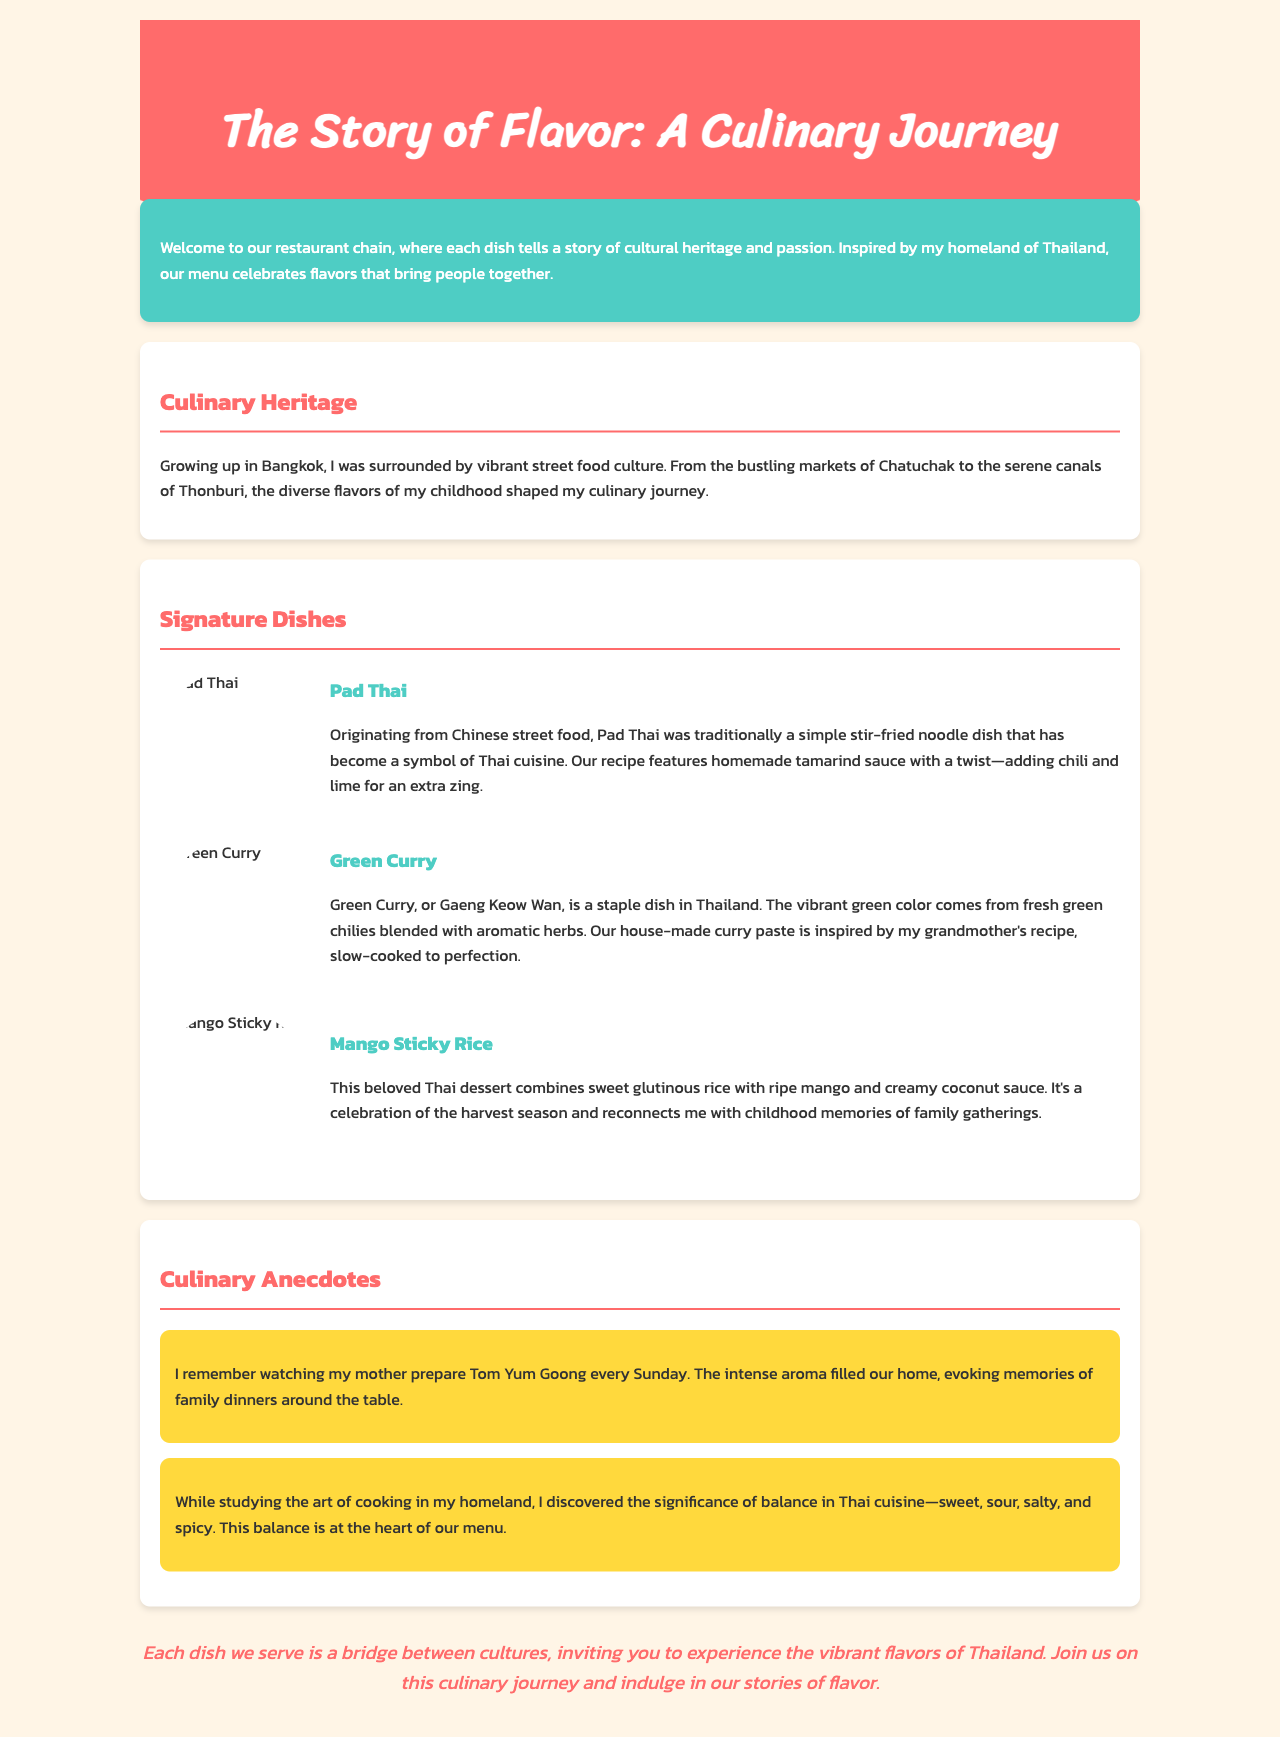What is the name of the restaurant chain? The brochure introduces the restaurant chain as celebrating flavors inspired by the owner's homeland.
Answer: Story of Flavor What is the main inspiration for the restaurant's menu? The brochure mentions that the menu is inspired by the owner's cultural heritage.
Answer: Culinary heritage What dish is described as a symbol of Thai cuisine? The text specifically identifies a dish that represents the essence of Thai cooking.
Answer: Pad Thai What ingredient gives the Green Curry its vibrant color? The document explains the source of the green color in one of the signature dishes.
Answer: Green chilies Which dessert is associated with family gatherings? The description of the dessert includes a nostalgic reference to childhood memories.
Answer: Mango Sticky Rice What is one key component of Thai cuisine mentioned in the anecdotes? The anecdotes highlight a crucial aspect that characterizes Thai culinary practices.
Answer: Balance How often did the author's mother prepare Tom Yum Goong? The document provides a specific detail related to frequency in the author's family cooking tradition.
Answer: Every Sunday What is the color theme of the header section? The color used in the header is described, giving visual context.
Answer: Red Which city is referred to as the owner's childhood home? The document specifies a location that influenced the owner's early culinary experiences.
Answer: Bangkok 